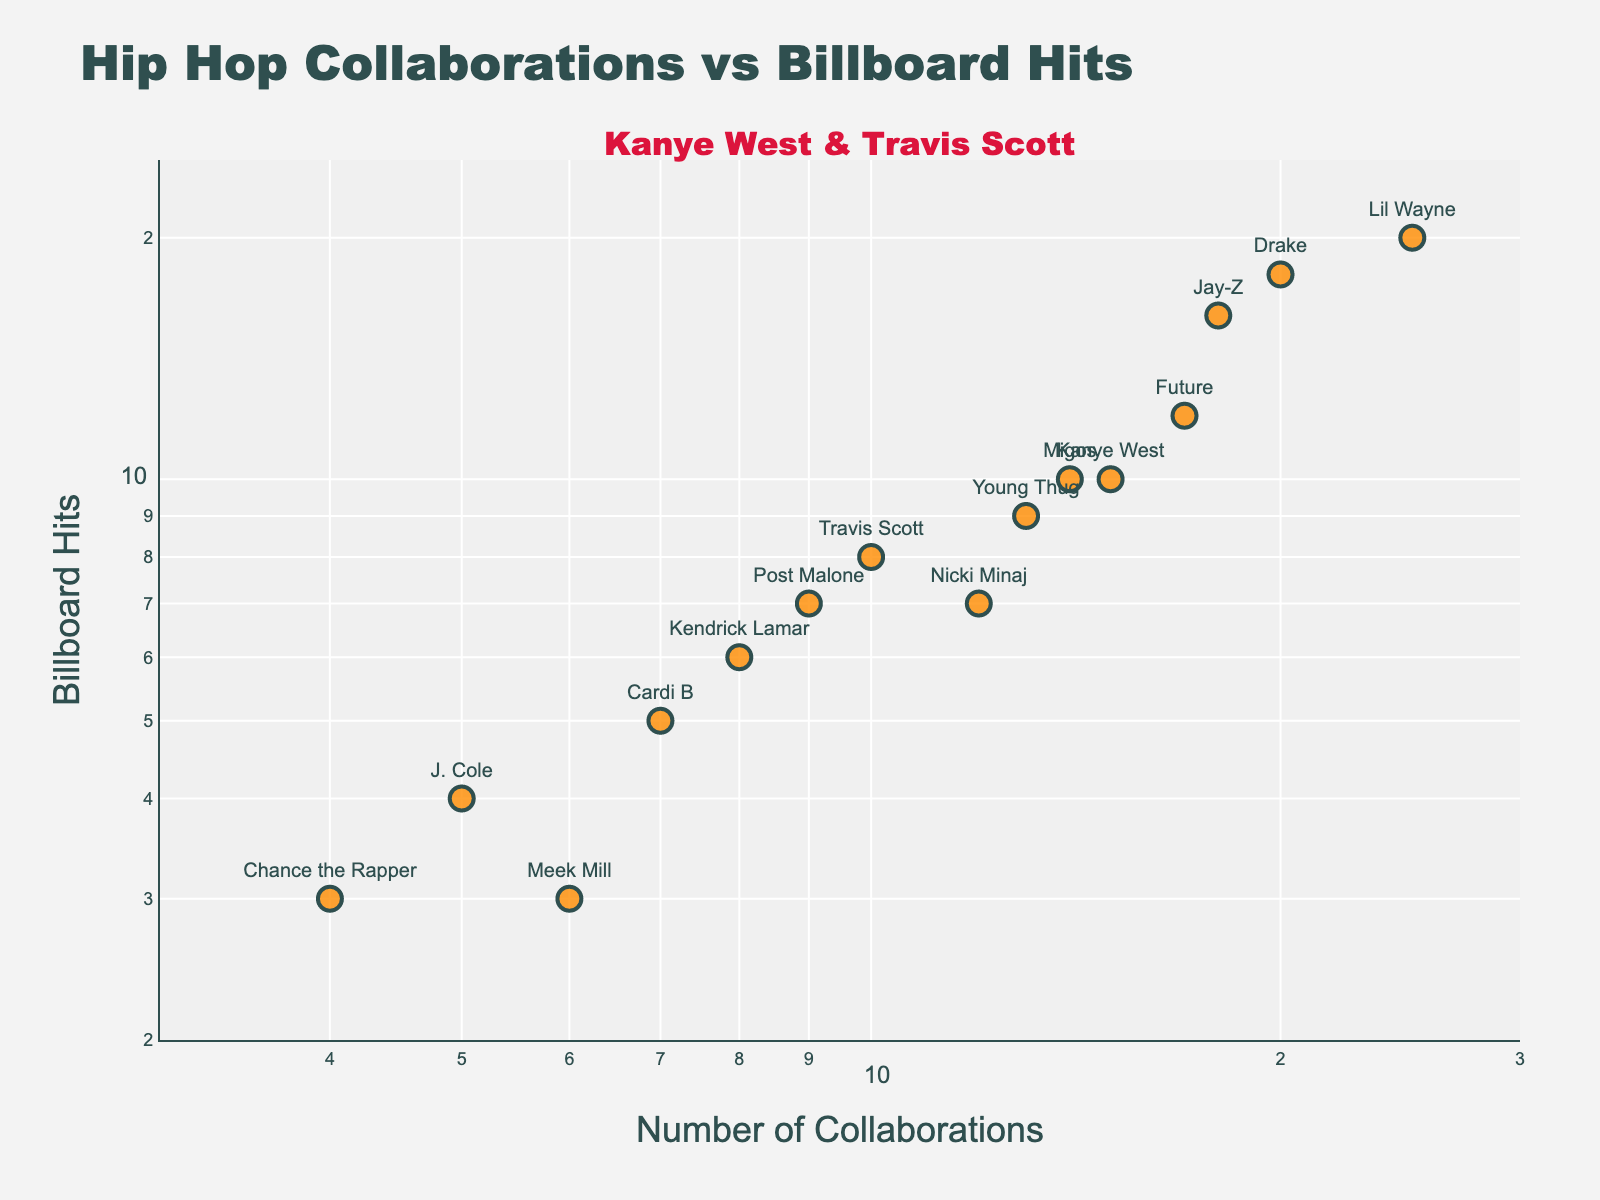How many artists are featured in the plot? The plot contains data points for each artist. By counting the data points, we can determine the number of artists.
Answer: 15 Which artist has the highest number of Billboard hits? Look at the y-axis and find the artist name associated with the highest data point.
Answer: Lil Wayne Do Kanye West and Travis Scott have an equal number of Billboard hits? Locate Kanye West and Travis Scott on the plot and compare their y-axis values.
Answer: No What range of values does the x-axis cover in terms of collaborations? The x-axis is on a log scale, and the tick marks indicate the minimum and maximum values.
Answer: 3 to 30 Which artist has the fewest Billboard hits and how many? Observe the data points on the plot and find the one with the lowest y-axis value.
Answer: Meek Mill, 3 What is the combined total of collaborations for Kanye West and Travis Scott? Summarize the plots of Kanye West and Travis Scott on the x-axis. Kanye has 15 and Travis has 10. Adding them gives 15 + 10.
Answer: 25 Which artist has more collaborations, Drake or Jay-Z? Find the data points for Drake and Jay-Z on the x-axis and compare their values.
Answer: Drake What's the relationship between the number of collaborations and Billboard hits for Nicki Minaj? Look at Nicki Minaj's data point to see her number of collaborations on the x-axis and Billboard hits on the y-axis.
Answer: 12 collaborations, 7 hits Who are the top two artists with the most collaborations, and how many does each have? Identify the data points furthest to the right on the x-axis.
Answer: Lil Wayne (25), Drake (20) Is there a general trend between the number of collaborations and the number of Billboard hits? Analyze the plot to see if there's a noticeable pattern or correlation between the x and y values.
Answer: Positive correlation 